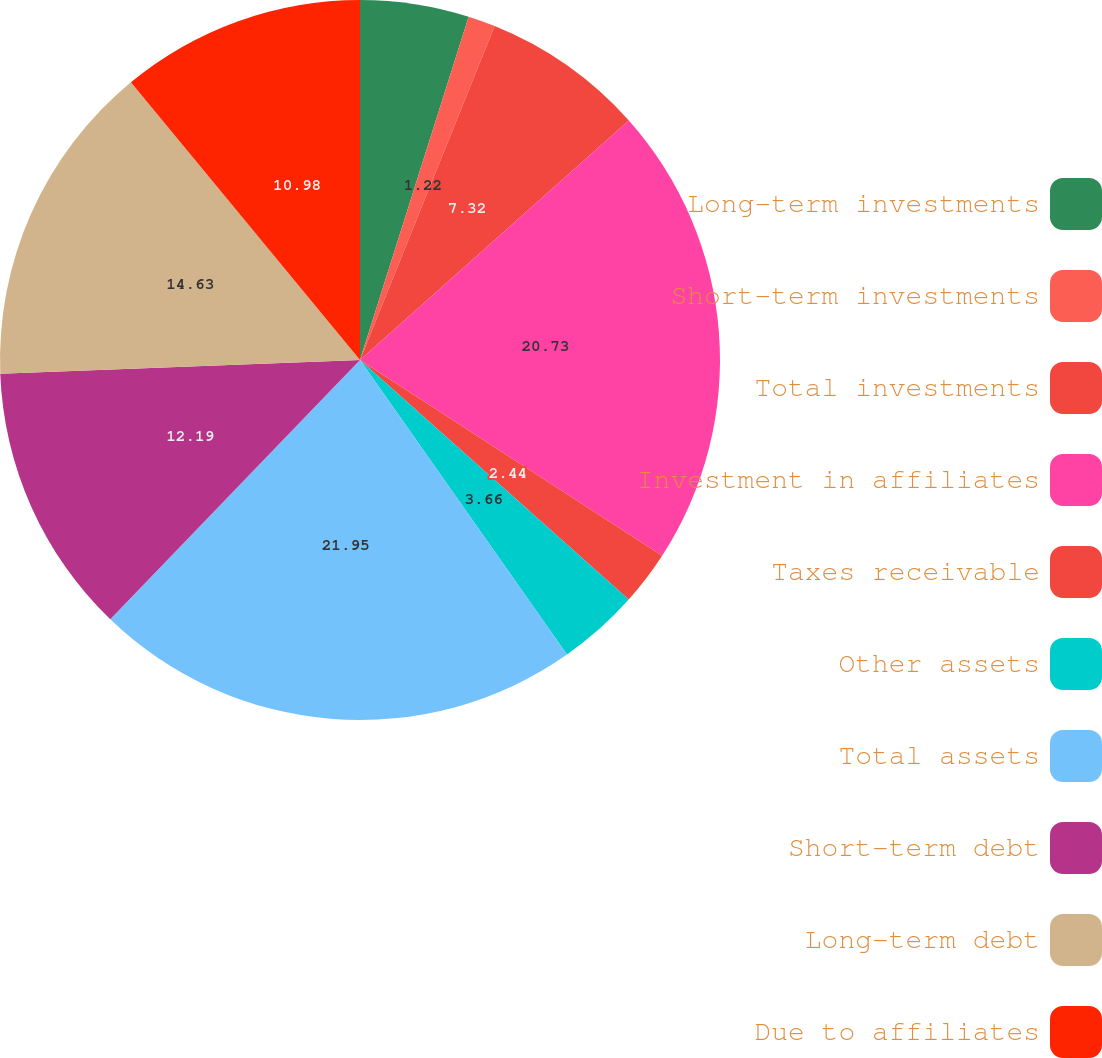<chart> <loc_0><loc_0><loc_500><loc_500><pie_chart><fcel>Long-term investments<fcel>Short-term investments<fcel>Total investments<fcel>Investment in affiliates<fcel>Taxes receivable<fcel>Other assets<fcel>Total assets<fcel>Short-term debt<fcel>Long-term debt<fcel>Due to affiliates<nl><fcel>4.88%<fcel>1.22%<fcel>7.32%<fcel>20.73%<fcel>2.44%<fcel>3.66%<fcel>21.95%<fcel>12.19%<fcel>14.63%<fcel>10.98%<nl></chart> 